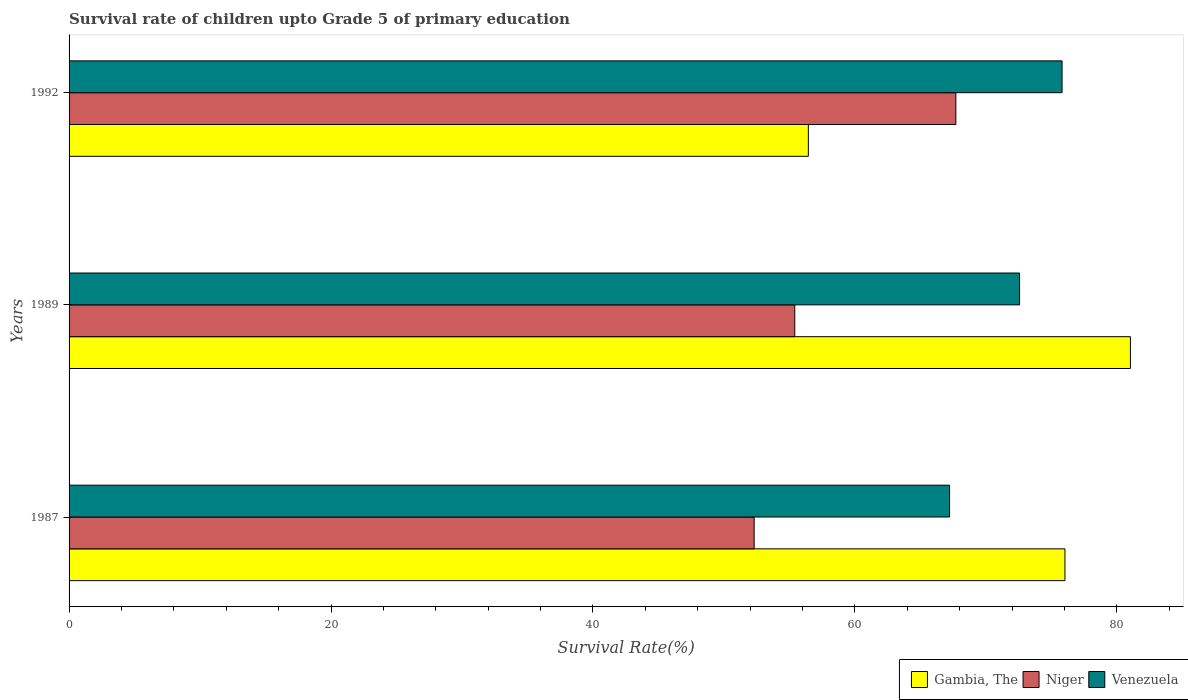How many different coloured bars are there?
Your answer should be very brief. 3. How many groups of bars are there?
Provide a short and direct response. 3. Are the number of bars per tick equal to the number of legend labels?
Give a very brief answer. Yes. How many bars are there on the 1st tick from the top?
Offer a terse response. 3. How many bars are there on the 1st tick from the bottom?
Your response must be concise. 3. What is the survival rate of children in Niger in 1987?
Offer a very short reply. 52.31. Across all years, what is the maximum survival rate of children in Niger?
Make the answer very short. 67.71. Across all years, what is the minimum survival rate of children in Venezuela?
Ensure brevity in your answer.  67.23. In which year was the survival rate of children in Venezuela maximum?
Your answer should be very brief. 1992. In which year was the survival rate of children in Venezuela minimum?
Ensure brevity in your answer.  1987. What is the total survival rate of children in Venezuela in the graph?
Your answer should be very brief. 215.63. What is the difference between the survival rate of children in Niger in 1987 and that in 1992?
Keep it short and to the point. -15.4. What is the difference between the survival rate of children in Gambia, The in 1987 and the survival rate of children in Niger in 1992?
Keep it short and to the point. 8.33. What is the average survival rate of children in Venezuela per year?
Your answer should be very brief. 71.88. In the year 1989, what is the difference between the survival rate of children in Venezuela and survival rate of children in Niger?
Give a very brief answer. 17.17. In how many years, is the survival rate of children in Venezuela greater than 4 %?
Your response must be concise. 3. What is the ratio of the survival rate of children in Venezuela in 1987 to that in 1989?
Provide a succinct answer. 0.93. Is the survival rate of children in Niger in 1987 less than that in 1989?
Keep it short and to the point. Yes. What is the difference between the highest and the second highest survival rate of children in Gambia, The?
Give a very brief answer. 5. What is the difference between the highest and the lowest survival rate of children in Venezuela?
Provide a succinct answer. 8.59. What does the 2nd bar from the top in 1989 represents?
Give a very brief answer. Niger. What does the 3rd bar from the bottom in 1989 represents?
Provide a short and direct response. Venezuela. Is it the case that in every year, the sum of the survival rate of children in Niger and survival rate of children in Venezuela is greater than the survival rate of children in Gambia, The?
Your response must be concise. Yes. Are all the bars in the graph horizontal?
Provide a short and direct response. Yes. How many years are there in the graph?
Offer a terse response. 3. What is the difference between two consecutive major ticks on the X-axis?
Ensure brevity in your answer.  20. Are the values on the major ticks of X-axis written in scientific E-notation?
Provide a succinct answer. No. Does the graph contain any zero values?
Your answer should be compact. No. Where does the legend appear in the graph?
Provide a short and direct response. Bottom right. How many legend labels are there?
Provide a succinct answer. 3. How are the legend labels stacked?
Your answer should be compact. Horizontal. What is the title of the graph?
Your answer should be very brief. Survival rate of children upto Grade 5 of primary education. What is the label or title of the X-axis?
Provide a succinct answer. Survival Rate(%). What is the Survival Rate(%) in Gambia, The in 1987?
Give a very brief answer. 76.04. What is the Survival Rate(%) of Niger in 1987?
Your answer should be compact. 52.31. What is the Survival Rate(%) in Venezuela in 1987?
Provide a succinct answer. 67.23. What is the Survival Rate(%) in Gambia, The in 1989?
Offer a very short reply. 81.04. What is the Survival Rate(%) of Niger in 1989?
Keep it short and to the point. 55.41. What is the Survival Rate(%) in Venezuela in 1989?
Keep it short and to the point. 72.58. What is the Survival Rate(%) of Gambia, The in 1992?
Offer a terse response. 56.45. What is the Survival Rate(%) of Niger in 1992?
Ensure brevity in your answer.  67.71. What is the Survival Rate(%) in Venezuela in 1992?
Offer a very short reply. 75.82. Across all years, what is the maximum Survival Rate(%) in Gambia, The?
Provide a short and direct response. 81.04. Across all years, what is the maximum Survival Rate(%) in Niger?
Your answer should be compact. 67.71. Across all years, what is the maximum Survival Rate(%) of Venezuela?
Ensure brevity in your answer.  75.82. Across all years, what is the minimum Survival Rate(%) of Gambia, The?
Your answer should be very brief. 56.45. Across all years, what is the minimum Survival Rate(%) in Niger?
Your answer should be very brief. 52.31. Across all years, what is the minimum Survival Rate(%) in Venezuela?
Your answer should be compact. 67.23. What is the total Survival Rate(%) of Gambia, The in the graph?
Make the answer very short. 213.53. What is the total Survival Rate(%) in Niger in the graph?
Your answer should be compact. 175.43. What is the total Survival Rate(%) in Venezuela in the graph?
Provide a short and direct response. 215.63. What is the difference between the Survival Rate(%) in Gambia, The in 1987 and that in 1989?
Ensure brevity in your answer.  -5. What is the difference between the Survival Rate(%) of Niger in 1987 and that in 1989?
Your response must be concise. -3.1. What is the difference between the Survival Rate(%) of Venezuela in 1987 and that in 1989?
Your response must be concise. -5.34. What is the difference between the Survival Rate(%) in Gambia, The in 1987 and that in 1992?
Offer a very short reply. 19.59. What is the difference between the Survival Rate(%) of Niger in 1987 and that in 1992?
Your answer should be compact. -15.4. What is the difference between the Survival Rate(%) in Venezuela in 1987 and that in 1992?
Ensure brevity in your answer.  -8.59. What is the difference between the Survival Rate(%) in Gambia, The in 1989 and that in 1992?
Make the answer very short. 24.59. What is the difference between the Survival Rate(%) in Niger in 1989 and that in 1992?
Provide a succinct answer. -12.3. What is the difference between the Survival Rate(%) of Venezuela in 1989 and that in 1992?
Give a very brief answer. -3.24. What is the difference between the Survival Rate(%) in Gambia, The in 1987 and the Survival Rate(%) in Niger in 1989?
Make the answer very short. 20.63. What is the difference between the Survival Rate(%) in Gambia, The in 1987 and the Survival Rate(%) in Venezuela in 1989?
Offer a terse response. 3.46. What is the difference between the Survival Rate(%) of Niger in 1987 and the Survival Rate(%) of Venezuela in 1989?
Offer a very short reply. -20.27. What is the difference between the Survival Rate(%) of Gambia, The in 1987 and the Survival Rate(%) of Niger in 1992?
Offer a very short reply. 8.33. What is the difference between the Survival Rate(%) of Gambia, The in 1987 and the Survival Rate(%) of Venezuela in 1992?
Ensure brevity in your answer.  0.22. What is the difference between the Survival Rate(%) in Niger in 1987 and the Survival Rate(%) in Venezuela in 1992?
Offer a very short reply. -23.51. What is the difference between the Survival Rate(%) in Gambia, The in 1989 and the Survival Rate(%) in Niger in 1992?
Your answer should be very brief. 13.33. What is the difference between the Survival Rate(%) in Gambia, The in 1989 and the Survival Rate(%) in Venezuela in 1992?
Your response must be concise. 5.22. What is the difference between the Survival Rate(%) of Niger in 1989 and the Survival Rate(%) of Venezuela in 1992?
Provide a succinct answer. -20.41. What is the average Survival Rate(%) of Gambia, The per year?
Your answer should be compact. 71.18. What is the average Survival Rate(%) of Niger per year?
Ensure brevity in your answer.  58.48. What is the average Survival Rate(%) in Venezuela per year?
Provide a succinct answer. 71.88. In the year 1987, what is the difference between the Survival Rate(%) of Gambia, The and Survival Rate(%) of Niger?
Provide a short and direct response. 23.73. In the year 1987, what is the difference between the Survival Rate(%) of Gambia, The and Survival Rate(%) of Venezuela?
Offer a terse response. 8.81. In the year 1987, what is the difference between the Survival Rate(%) in Niger and Survival Rate(%) in Venezuela?
Give a very brief answer. -14.92. In the year 1989, what is the difference between the Survival Rate(%) of Gambia, The and Survival Rate(%) of Niger?
Your response must be concise. 25.63. In the year 1989, what is the difference between the Survival Rate(%) of Gambia, The and Survival Rate(%) of Venezuela?
Your answer should be compact. 8.46. In the year 1989, what is the difference between the Survival Rate(%) in Niger and Survival Rate(%) in Venezuela?
Make the answer very short. -17.17. In the year 1992, what is the difference between the Survival Rate(%) in Gambia, The and Survival Rate(%) in Niger?
Offer a terse response. -11.26. In the year 1992, what is the difference between the Survival Rate(%) of Gambia, The and Survival Rate(%) of Venezuela?
Give a very brief answer. -19.37. In the year 1992, what is the difference between the Survival Rate(%) in Niger and Survival Rate(%) in Venezuela?
Offer a terse response. -8.11. What is the ratio of the Survival Rate(%) in Gambia, The in 1987 to that in 1989?
Give a very brief answer. 0.94. What is the ratio of the Survival Rate(%) of Niger in 1987 to that in 1989?
Give a very brief answer. 0.94. What is the ratio of the Survival Rate(%) in Venezuela in 1987 to that in 1989?
Your answer should be very brief. 0.93. What is the ratio of the Survival Rate(%) in Gambia, The in 1987 to that in 1992?
Provide a succinct answer. 1.35. What is the ratio of the Survival Rate(%) in Niger in 1987 to that in 1992?
Provide a succinct answer. 0.77. What is the ratio of the Survival Rate(%) in Venezuela in 1987 to that in 1992?
Keep it short and to the point. 0.89. What is the ratio of the Survival Rate(%) in Gambia, The in 1989 to that in 1992?
Give a very brief answer. 1.44. What is the ratio of the Survival Rate(%) of Niger in 1989 to that in 1992?
Provide a short and direct response. 0.82. What is the ratio of the Survival Rate(%) in Venezuela in 1989 to that in 1992?
Your response must be concise. 0.96. What is the difference between the highest and the second highest Survival Rate(%) in Gambia, The?
Provide a short and direct response. 5. What is the difference between the highest and the second highest Survival Rate(%) of Niger?
Your answer should be very brief. 12.3. What is the difference between the highest and the second highest Survival Rate(%) in Venezuela?
Your answer should be very brief. 3.24. What is the difference between the highest and the lowest Survival Rate(%) in Gambia, The?
Keep it short and to the point. 24.59. What is the difference between the highest and the lowest Survival Rate(%) in Niger?
Offer a very short reply. 15.4. What is the difference between the highest and the lowest Survival Rate(%) of Venezuela?
Offer a very short reply. 8.59. 